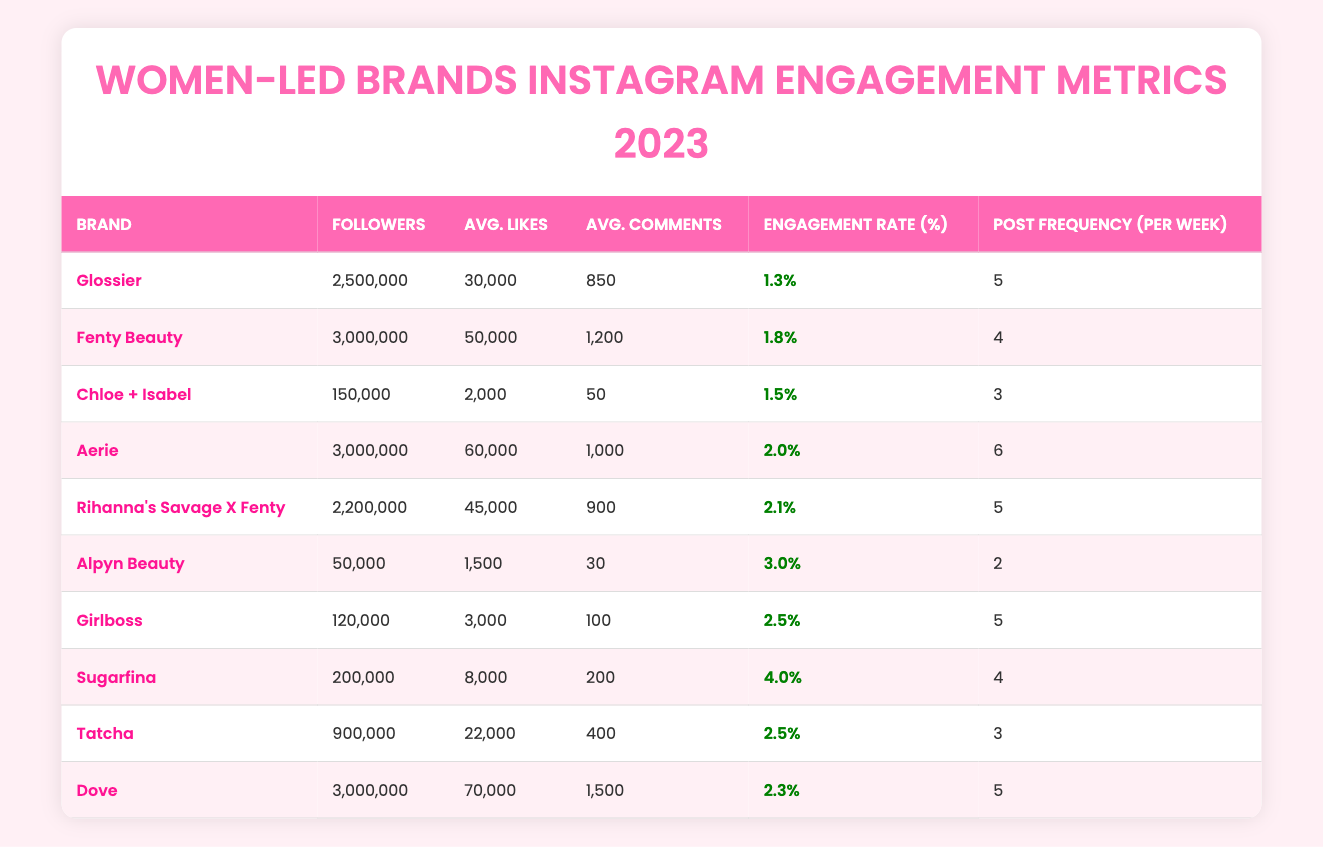What is the engagement rate of Aerie? In the table, I find the row for Aerie and look at the Engagement Rate column which shows the value for Aerie. The engagement rate for Aerie is listed as 2.0%.
Answer: 2.0% How many followers does Glossier have? The table has a row for Glossier and I check the Followers column. The number of followers for Glossier is 2,500,000.
Answer: 2,500,000 Which brand has the highest average likes? I scan the Average Likes column to compare the values. The maximum value appears beside the brand Sugarfina, which has 8,000 average likes, greater than any other brand listed.
Answer: Sugarfina What is the total average likes of the brands with more than 1 million followers? First, I identify the brands with more than 1 million followers: Glossier, Fenty Beauty, Aerie, Dove. Then, I add their average likes: 30,000 (Glossier) + 50,000 (Fenty Beauty) + 60,000 (Aerie) + 70,000 (Dove) = 210,000. Finally, I get the total average likes.
Answer: 210,000 Is Sugarfina’s engagement rate higher than Glossier’s? I check the Engagement Rate column for both brands. Sugarfina's engagement rate is 4.0% and Glossier's is 1.3%. Since 4.0% is greater than 1.3%, the answer is yes.
Answer: Yes Which brand has the lowest engagement rate and what is that rate? I look at the Engagement Rate column, comparing the values to find the lowest. The brand with the lowest engagement rate is Glossier at 1.3%.
Answer: Glossier, 1.3% How many brands have an engagement rate greater than 2.0%? I count the engagement rates in the table that are above 2.0%: Aerie (2.0%), Rihanna's Savage X Fenty (2.1%), Alpyn Beauty (3.0%), Girlboss (2.5%), Sugarfina (4.0%). There are five brands with rates over 2.0%.
Answer: 5 What is the difference between the average number of comments for Dove and Chloe + Isabel? I check the Average Comments column for both brands: Dove has 1,500 comments and Chloe + Isabel has 50 comments. The difference is calculated as 1,500 - 50 = 1,450.
Answer: 1,450 Which brand has the highest post frequency per week? I check the Post Frequency column and find Aerie has the highest frequency with 6 posts per week, which is more than any other brand listed.
Answer: Aerie 